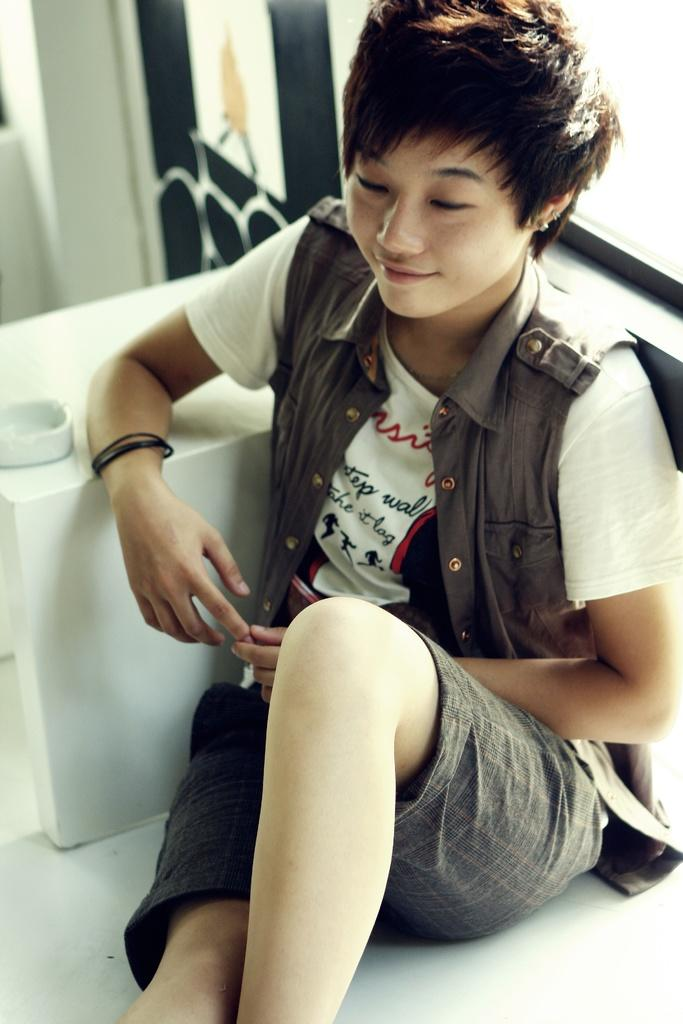What is the main subject of the image? The main subject of the image is a woman. What is the woman doing in the image? The woman is sitting on a chair. What type of worm can be seen crawling on the woman's chair in the image? There is no worm present in the image, and therefore no such activity can be observed. 